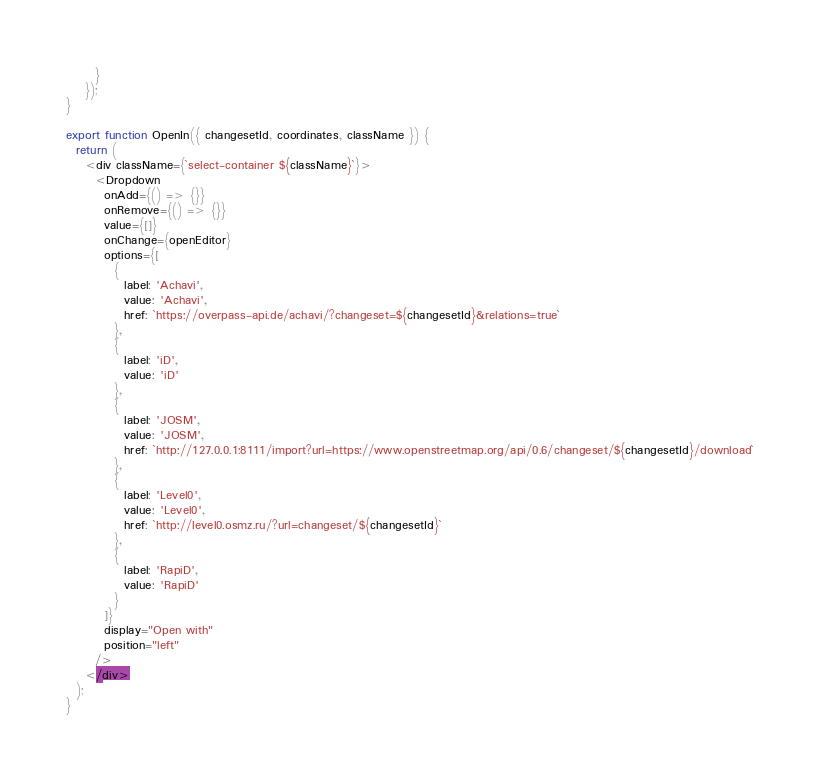Convert code to text. <code><loc_0><loc_0><loc_500><loc_500><_JavaScript_>      }
    });
}

export function OpenIn({ changesetId, coordinates, className }) {
  return (
    <div className={`select-container ${className}`}>
      <Dropdown
        onAdd={() => {}}
        onRemove={() => {}}
        value={[]}
        onChange={openEditor}
        options={[
          {
            label: 'Achavi',
            value: 'Achavi',
            href: `https://overpass-api.de/achavi/?changeset=${changesetId}&relations=true`
          },
          {
            label: 'iD',
            value: 'iD'
          },
          {
            label: 'JOSM',
            value: 'JOSM',
            href: `http://127.0.0.1:8111/import?url=https://www.openstreetmap.org/api/0.6/changeset/${changesetId}/download`
          },
          {
            label: 'Level0',
            value: 'Level0',
            href: `http://level0.osmz.ru/?url=changeset/${changesetId}`
          },
          {
            label: 'RapiD',
            value: 'RapiD'
          }
        ]}
        display="Open with"
        position="left"
      />
    </div>
  );
}
</code> 